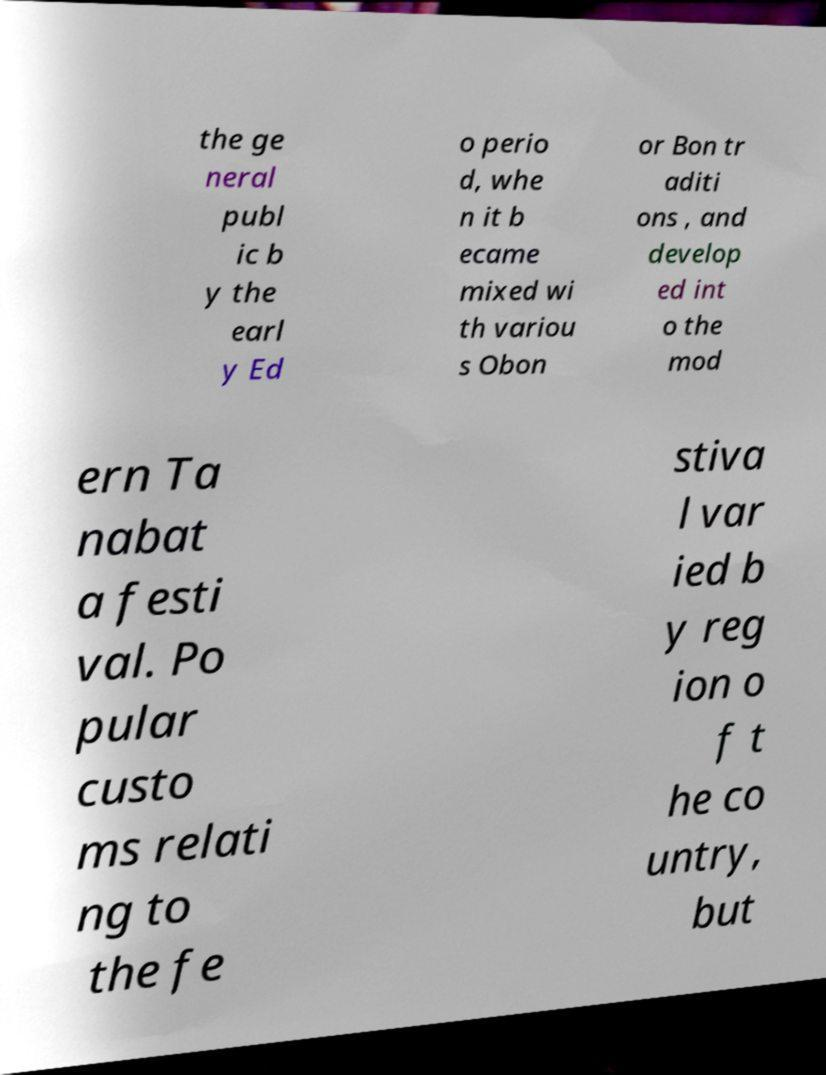Could you assist in decoding the text presented in this image and type it out clearly? the ge neral publ ic b y the earl y Ed o perio d, whe n it b ecame mixed wi th variou s Obon or Bon tr aditi ons , and develop ed int o the mod ern Ta nabat a festi val. Po pular custo ms relati ng to the fe stiva l var ied b y reg ion o f t he co untry, but 